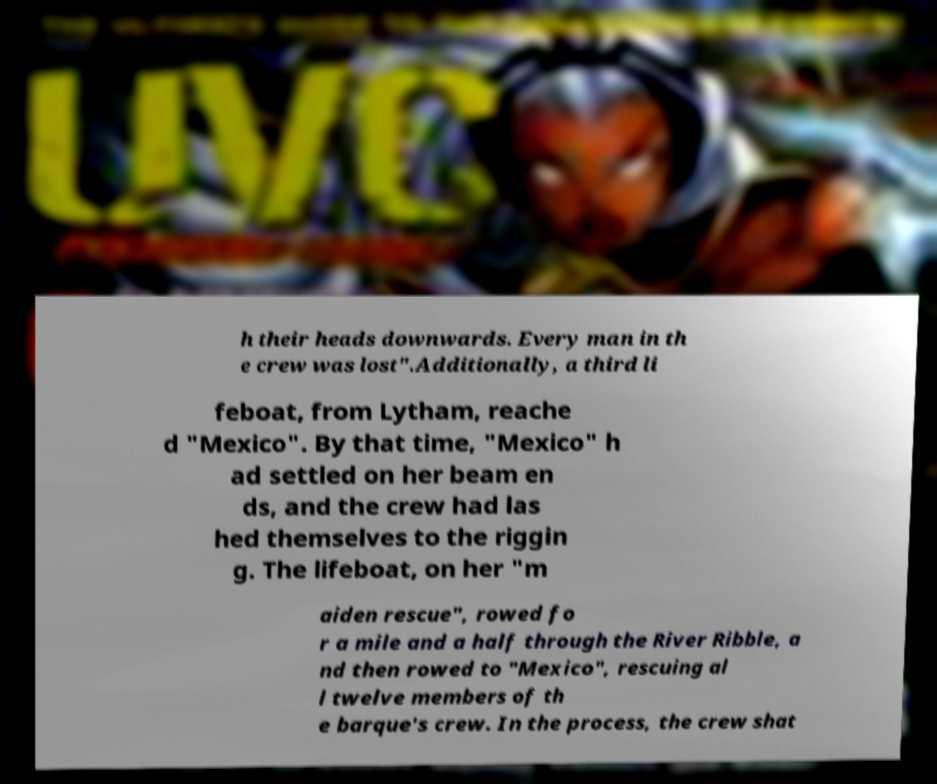There's text embedded in this image that I need extracted. Can you transcribe it verbatim? h their heads downwards. Every man in th e crew was lost".Additionally, a third li feboat, from Lytham, reache d "Mexico". By that time, "Mexico" h ad settled on her beam en ds, and the crew had las hed themselves to the riggin g. The lifeboat, on her "m aiden rescue", rowed fo r a mile and a half through the River Ribble, a nd then rowed to "Mexico", rescuing al l twelve members of th e barque's crew. In the process, the crew shat 